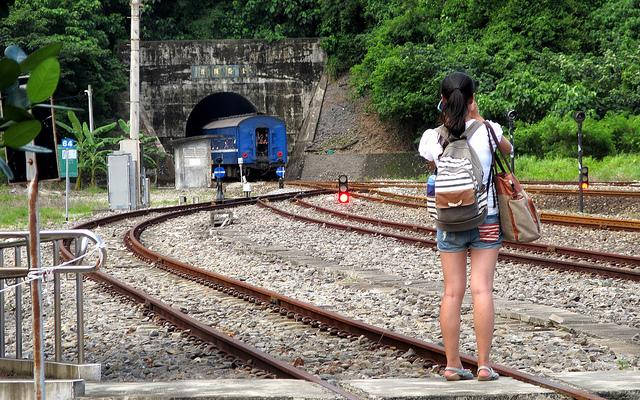What is the girl wearing? Please explain your reasoning. sandals. Her feet are not completely covered. 